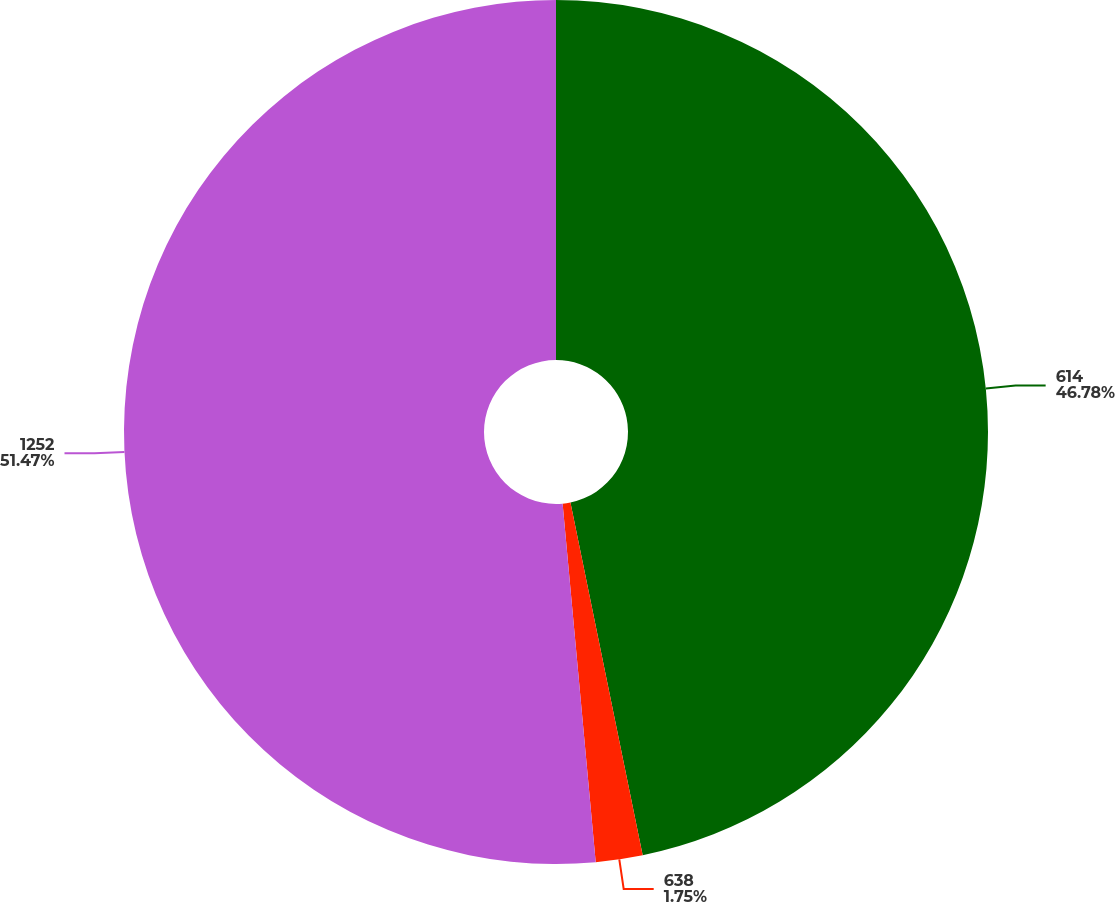Convert chart. <chart><loc_0><loc_0><loc_500><loc_500><pie_chart><fcel>614<fcel>638<fcel>1252<nl><fcel>46.78%<fcel>1.75%<fcel>51.46%<nl></chart> 